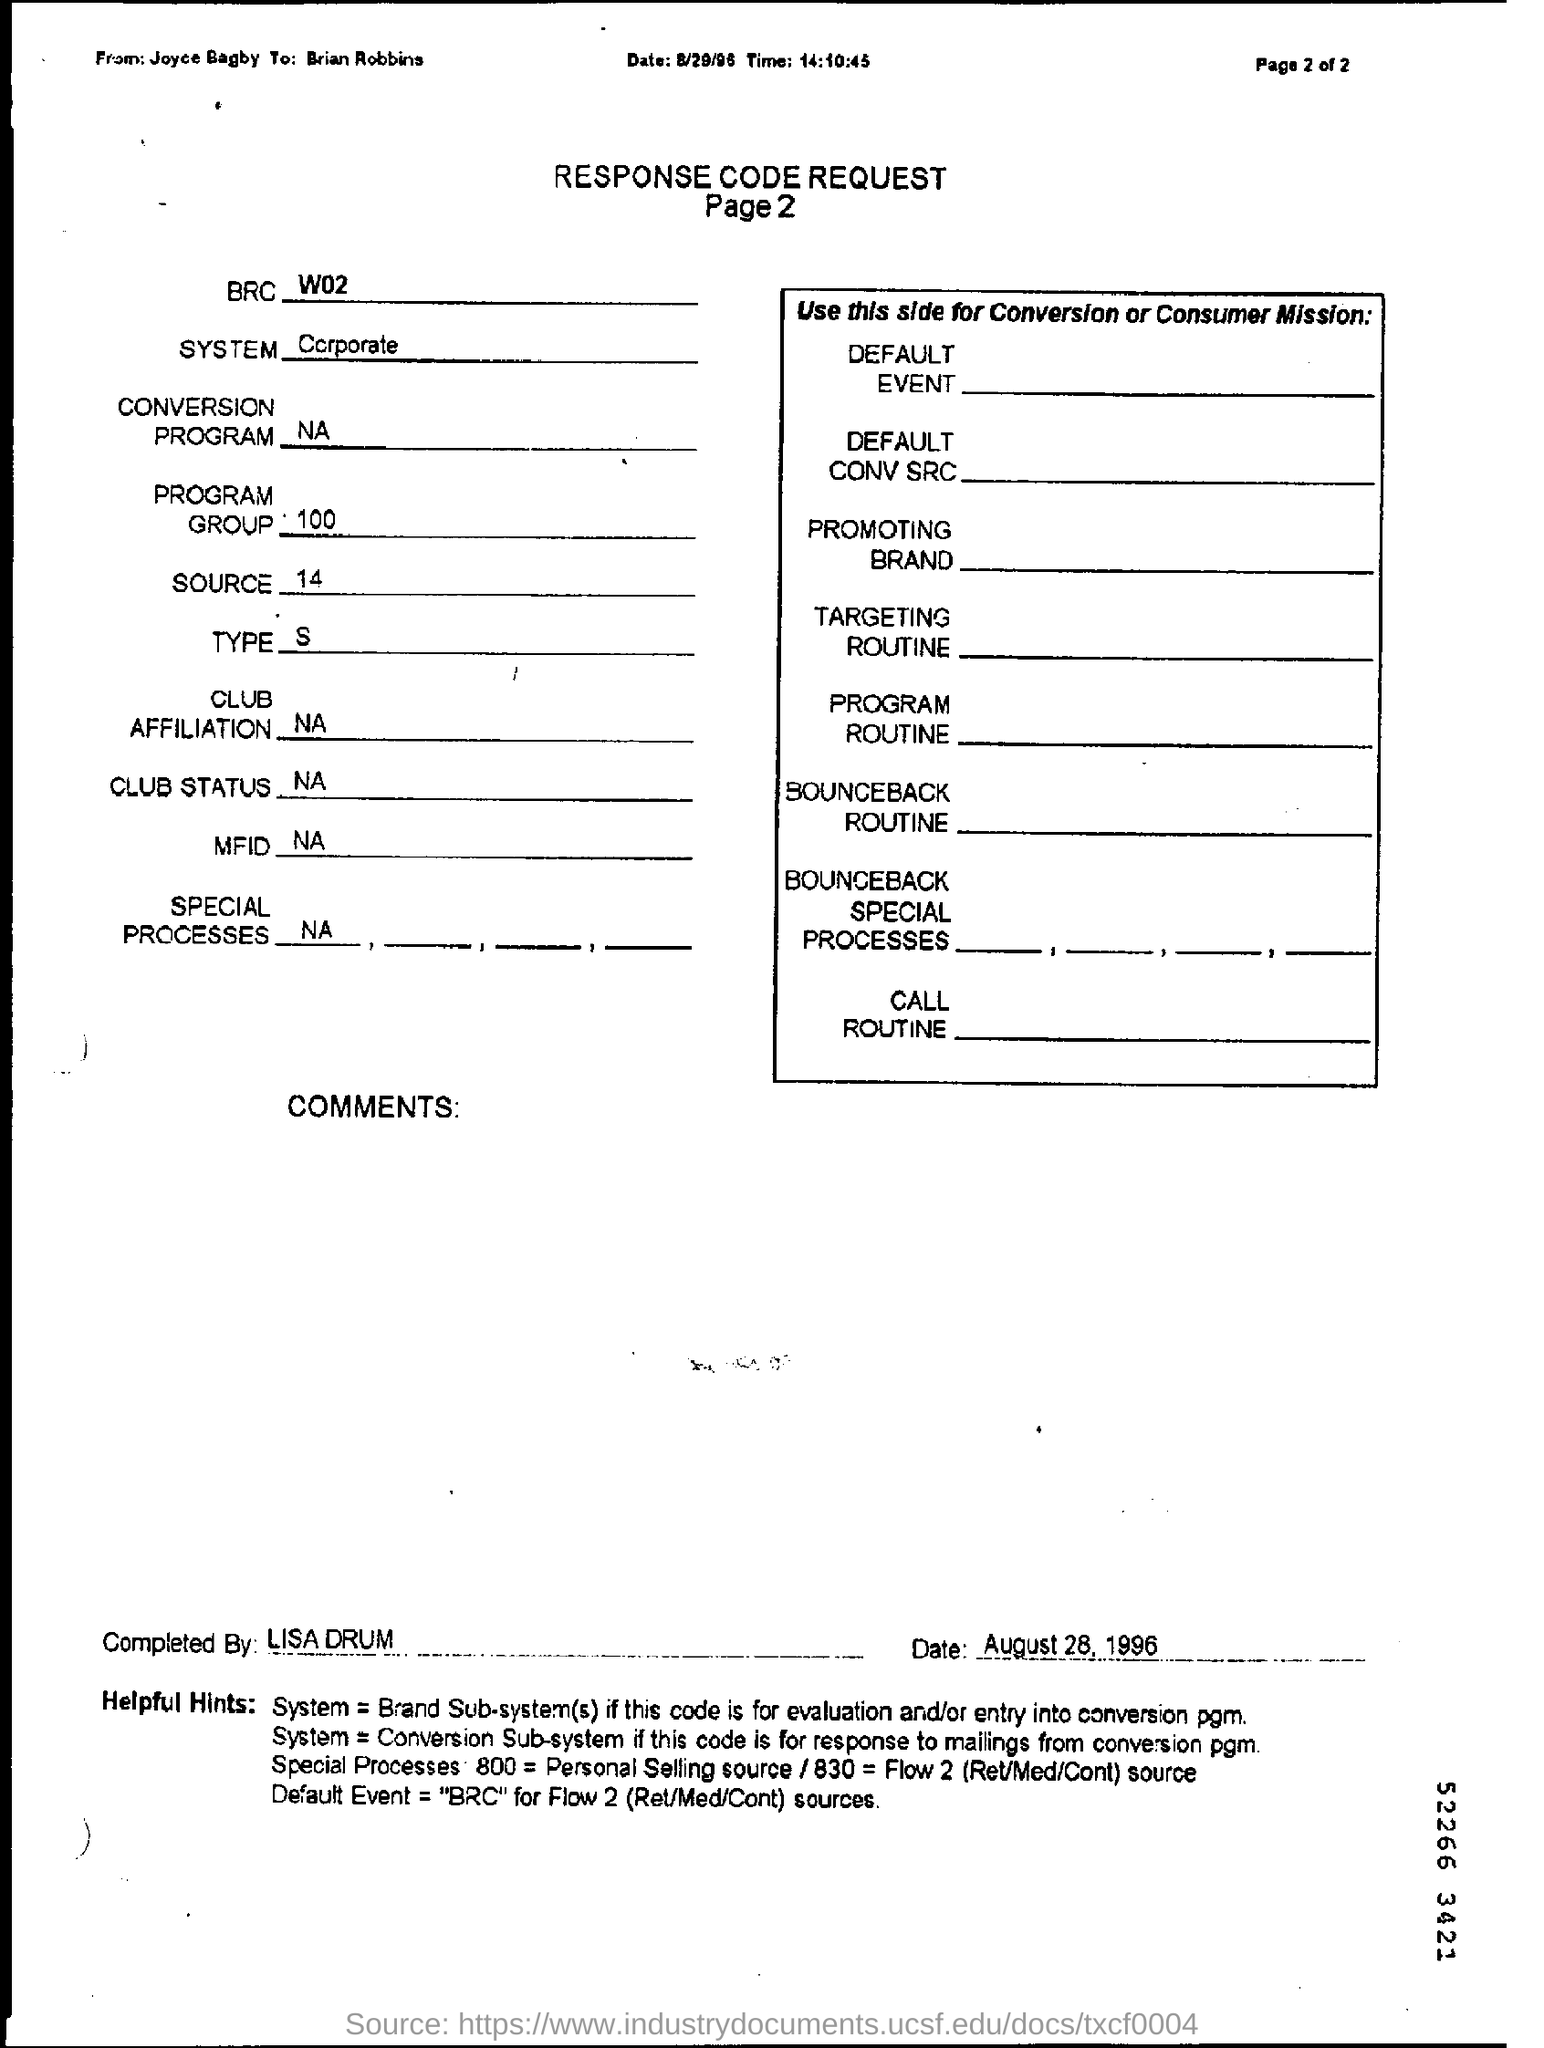What is the purpose of this document? This document seems to be a 'Response Code Request' form, which is likely used to track responses or conversions for a marketing or sales campaign. It includes fields for system designation, conversion programs, target audience, promotional brand, and other specific routines and processes associated with responding to customer interactions or inquiries. 